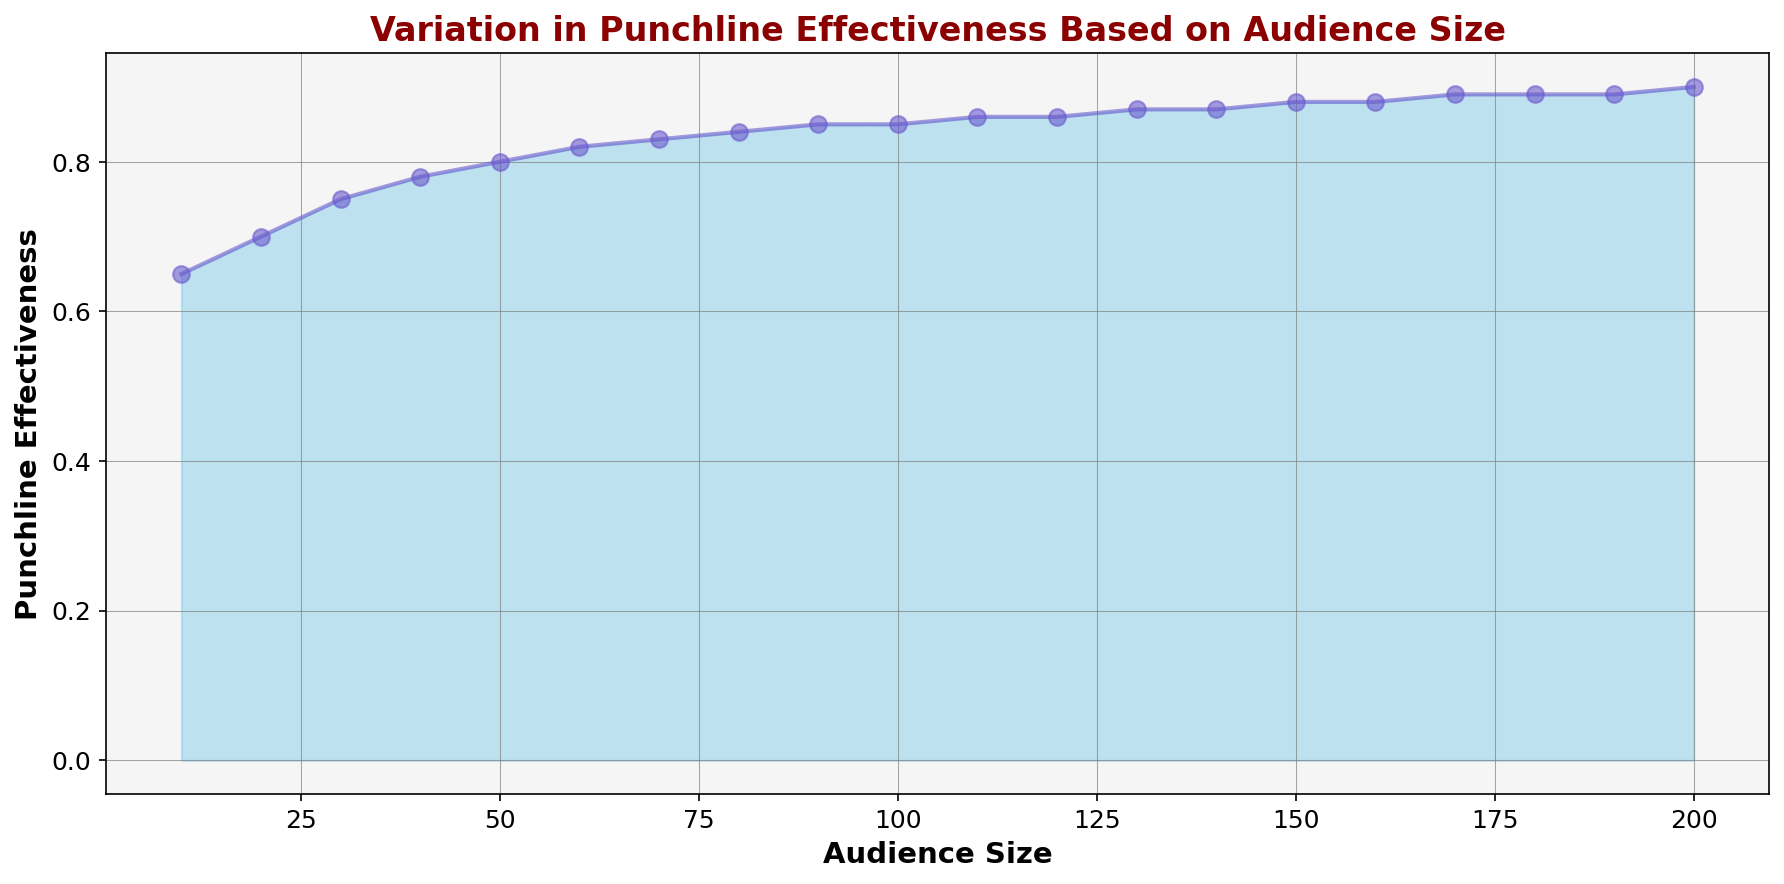What is the maximum punchline effectiveness shown in the figure? The highest point on the Y-axis indicates the maximum punchline effectiveness. Here, it reaches up to 0.90.
Answer: 0.90 How does the punchline effectiveness change as the audience size increases from 10 to 200? As the audience size increases from 10 to 200, the punchline effectiveness gradually increases, starting from 0.65 and reaching a maximum of 0.90.
Answer: It increases Which audience size shows a punchline effectiveness of 0.88? By examining the points meticulously on the graph, it shows a punchline effectiveness of 0.88 at both audience sizes 150 and 160.
Answer: 150 and 160 What is the difference in punchline effectiveness between the smallest and largest audience sizes? The punchline effectiveness at an audience size of 10 is 0.65, and at an audience size of 200, it is 0.90. The difference is 0.90 - 0.65 = 0.25.
Answer: 0.25 At what point does the increasing trend in punchline effectiveness start to level off? Observing the chart, punchline effectiveness growth begins to level off at around an audience size of 100, where the effectiveness value starts to stabilize around 0.85.
Answer: 100 Is there any point where the punchline effectiveness does not change for two consecutive audience sizes? Yes, from audience sizes 90 to 100 and 110 to 120, punchline effectiveness remains constant at 0.85 and 0.86, respectively.
Answer: Yes What is the average punchline effectiveness for audience sizes between 50 and 100? The punchline effectiveness for audience sizes 50, 60, 70, 80, 90, and 100 are 0.80, 0.82, 0.83, 0.84, 0.85, and 0.85, respectively. The average is calculated as (0.80 + 0.82 + 0.83 + 0.84 + 0.85 + 0.85) / 6 ≈ 0.83.
Answer: 0.83 Which has a greater increase in punchline effectiveness: the change from an audience size of 10 to 50 or from 50 to 90? From 10 to 50, punchline effectiveness increases from 0.65 to 0.80, a change of 0.15. From 50 to 90, it increases from 0.80 to 0.85, a change of 0.05. The greater increase is from 10 to 50.
Answer: 10 to 50 What percentage of the total audience size range does the interval between 100 and 200 cover? The total audience size range is from 10 to 200, i.e., 200 - 10 = 190. The interval 100 to 200 covers 200 - 100 = 100. The percentage is (100 / 190) * 100 ≈ 52.63%.
Answer: 52.63% 